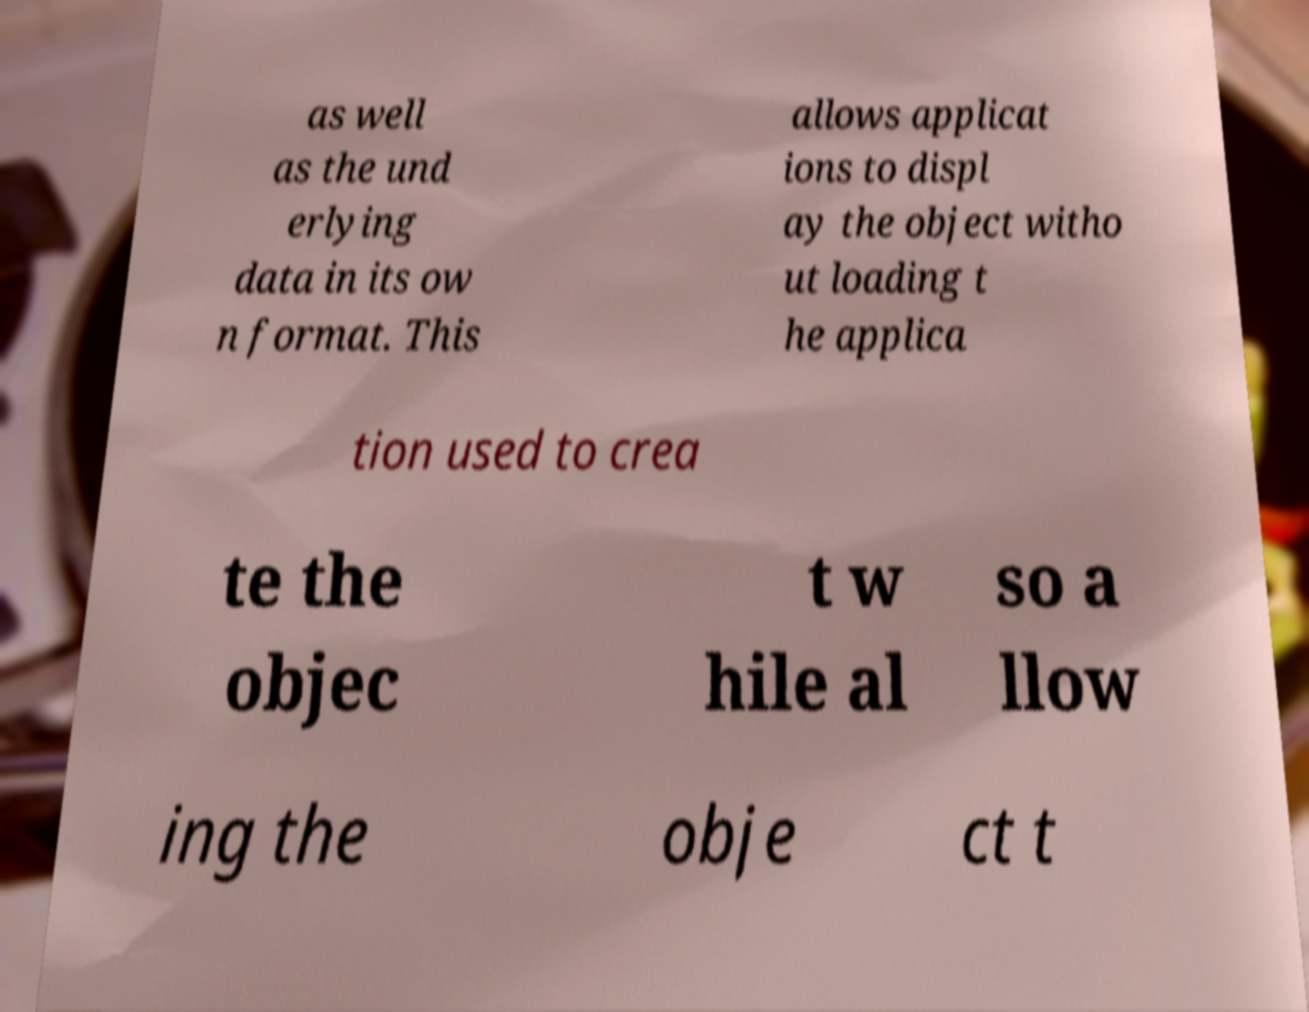Could you extract and type out the text from this image? as well as the und erlying data in its ow n format. This allows applicat ions to displ ay the object witho ut loading t he applica tion used to crea te the objec t w hile al so a llow ing the obje ct t 